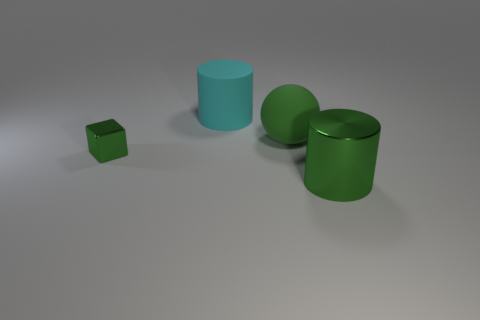Is the metallic cylinder the same size as the green metal block?
Keep it short and to the point. No. Is there a small green cube made of the same material as the green cylinder?
Offer a very short reply. Yes. What size is the metal cylinder that is the same color as the sphere?
Make the answer very short. Large. What number of green objects are both in front of the green rubber object and to the right of the cyan rubber object?
Give a very brief answer. 1. What material is the green thing that is left of the large cyan cylinder?
Offer a terse response. Metal. How many matte cubes are the same color as the tiny object?
Your answer should be compact. 0. What size is the other green thing that is made of the same material as the small thing?
Your answer should be very brief. Large. How many objects are green cylinders or green things?
Make the answer very short. 3. What color is the large metal cylinder in front of the tiny shiny cube?
Offer a terse response. Green. What is the size of the other thing that is the same shape as the large cyan object?
Your response must be concise. Large. 